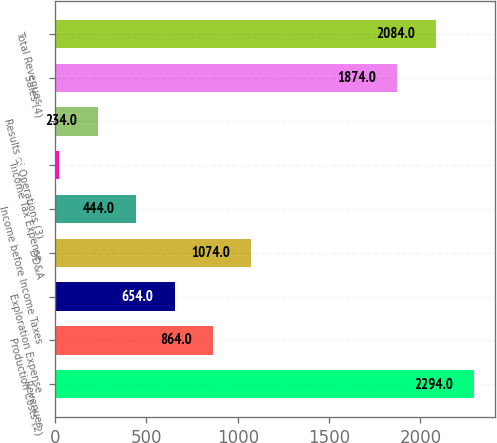<chart> <loc_0><loc_0><loc_500><loc_500><bar_chart><fcel>Revenues<fcel>Production Costs (2)<fcel>Exploration Expense<fcel>DD&A<fcel>Income before Income Taxes<fcel>Income Tax Expense<fcel>Results of Operations (3)<fcel>Sales (4)<fcel>Total Revenues<nl><fcel>2294<fcel>864<fcel>654<fcel>1074<fcel>444<fcel>24<fcel>234<fcel>1874<fcel>2084<nl></chart> 